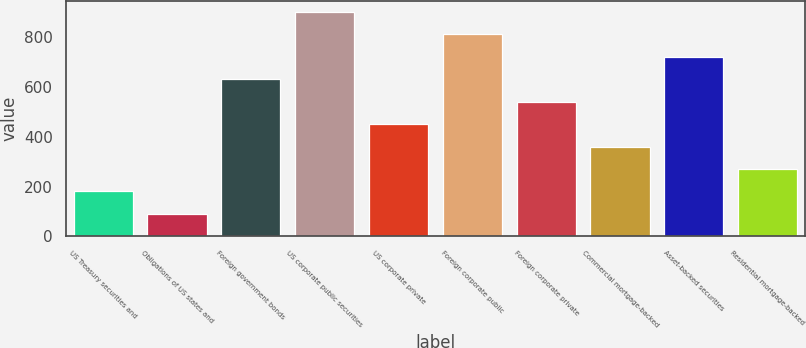Convert chart. <chart><loc_0><loc_0><loc_500><loc_500><bar_chart><fcel>US Treasury securities and<fcel>Obligations of US states and<fcel>Foreign government bonds<fcel>US corporate public securities<fcel>US corporate private<fcel>Foreign corporate public<fcel>Foreign corporate private<fcel>Commercial mortgage-backed<fcel>Asset-backed securities<fcel>Residential mortgage-backed<nl><fcel>181<fcel>91<fcel>631<fcel>901<fcel>451<fcel>811<fcel>541<fcel>361<fcel>721<fcel>271<nl></chart> 